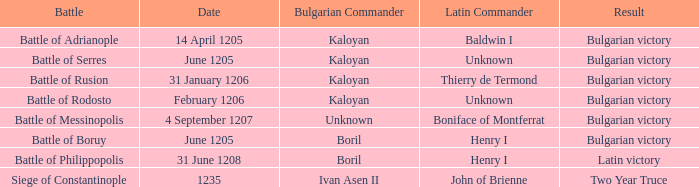Who is the latin commander during the siege of constantinople? John of Brienne. 